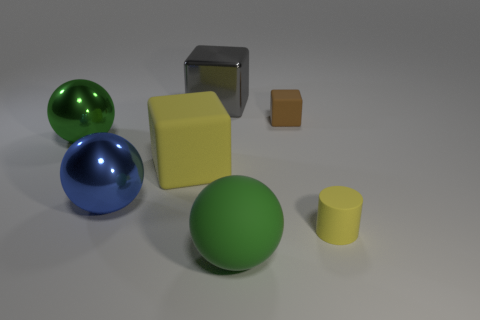Add 1 large purple cubes. How many objects exist? 8 Subtract all cubes. How many objects are left? 4 Add 3 big rubber objects. How many big rubber objects exist? 5 Subtract 0 purple spheres. How many objects are left? 7 Subtract all large blue metallic things. Subtract all tiny blocks. How many objects are left? 5 Add 4 tiny blocks. How many tiny blocks are left? 5 